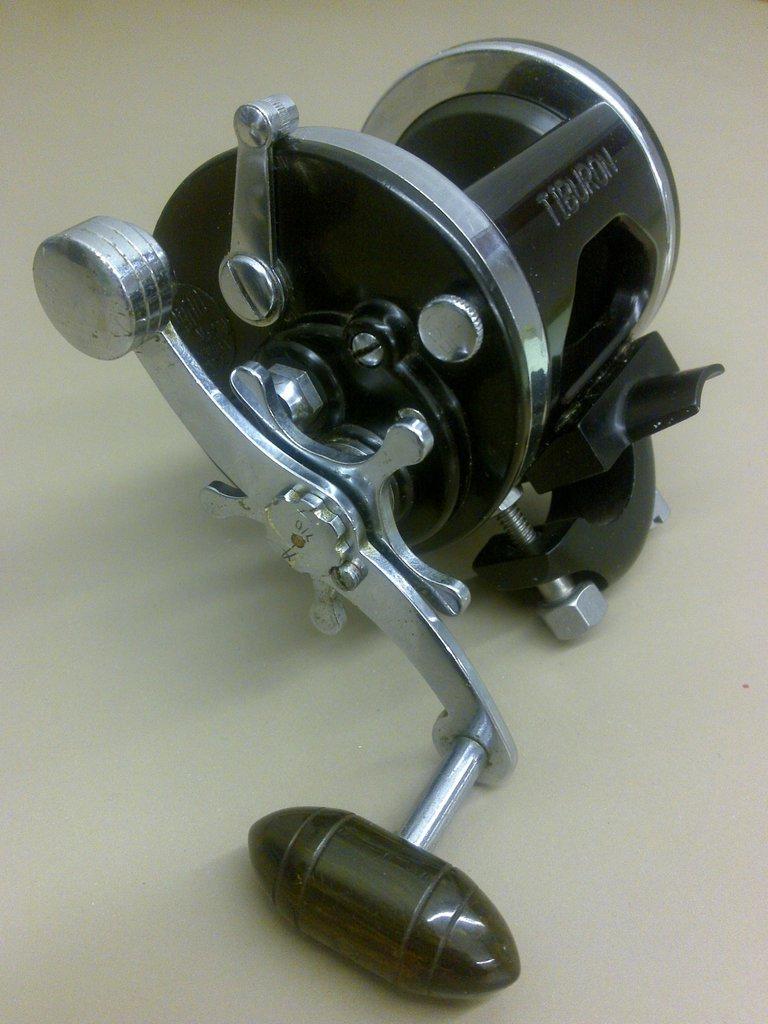How would you summarize this image in a sentence or two? In the center of the image there is a object. 